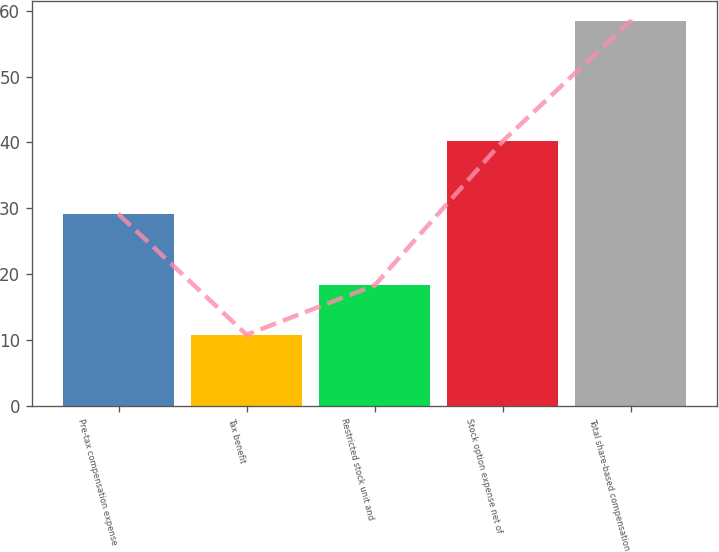Convert chart. <chart><loc_0><loc_0><loc_500><loc_500><bar_chart><fcel>Pre-tax compensation expense<fcel>Tax benefit<fcel>Restricted stock unit and<fcel>Stock option expense net of<fcel>Total share-based compensation<nl><fcel>29.1<fcel>10.8<fcel>18.3<fcel>40.2<fcel>58.5<nl></chart> 